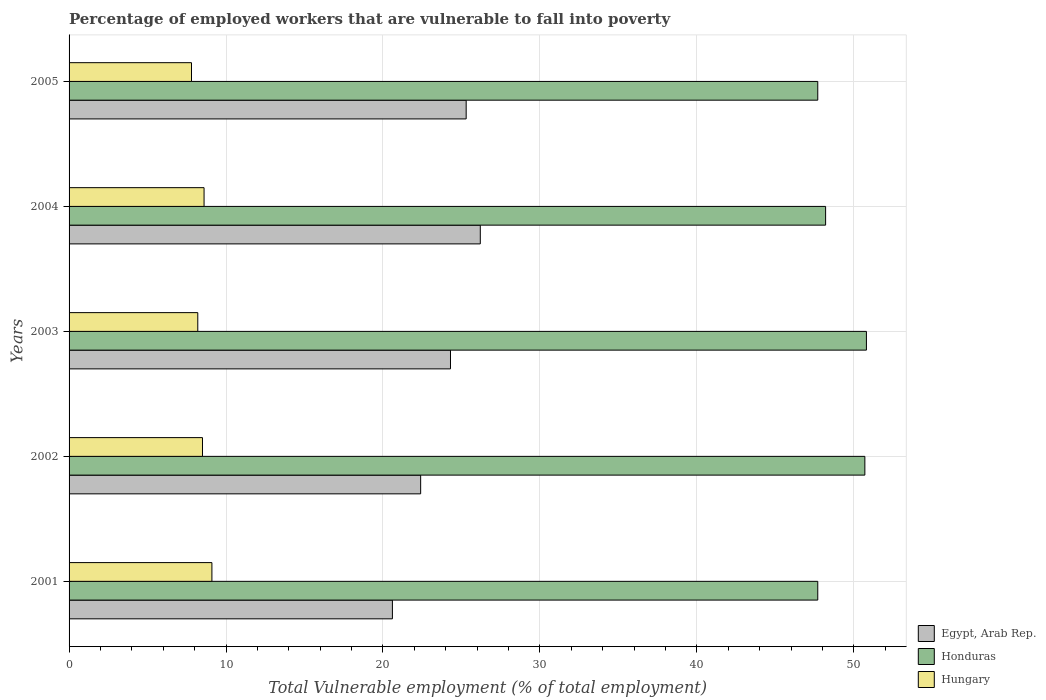How many different coloured bars are there?
Give a very brief answer. 3. How many bars are there on the 1st tick from the top?
Provide a succinct answer. 3. What is the label of the 5th group of bars from the top?
Keep it short and to the point. 2001. What is the percentage of employed workers who are vulnerable to fall into poverty in Egypt, Arab Rep. in 2004?
Your response must be concise. 26.2. Across all years, what is the maximum percentage of employed workers who are vulnerable to fall into poverty in Hungary?
Offer a terse response. 9.1. Across all years, what is the minimum percentage of employed workers who are vulnerable to fall into poverty in Hungary?
Keep it short and to the point. 7.8. What is the total percentage of employed workers who are vulnerable to fall into poverty in Honduras in the graph?
Give a very brief answer. 245.1. What is the difference between the percentage of employed workers who are vulnerable to fall into poverty in Egypt, Arab Rep. in 2001 and that in 2002?
Your response must be concise. -1.8. What is the difference between the percentage of employed workers who are vulnerable to fall into poverty in Honduras in 2004 and the percentage of employed workers who are vulnerable to fall into poverty in Egypt, Arab Rep. in 2001?
Offer a very short reply. 27.6. What is the average percentage of employed workers who are vulnerable to fall into poverty in Honduras per year?
Provide a succinct answer. 49.02. In the year 2001, what is the difference between the percentage of employed workers who are vulnerable to fall into poverty in Egypt, Arab Rep. and percentage of employed workers who are vulnerable to fall into poverty in Honduras?
Give a very brief answer. -27.1. In how many years, is the percentage of employed workers who are vulnerable to fall into poverty in Hungary greater than 12 %?
Provide a short and direct response. 0. What is the ratio of the percentage of employed workers who are vulnerable to fall into poverty in Honduras in 2001 to that in 2002?
Ensure brevity in your answer.  0.94. Is the percentage of employed workers who are vulnerable to fall into poverty in Honduras in 2001 less than that in 2004?
Provide a succinct answer. Yes. Is the difference between the percentage of employed workers who are vulnerable to fall into poverty in Egypt, Arab Rep. in 2001 and 2005 greater than the difference between the percentage of employed workers who are vulnerable to fall into poverty in Honduras in 2001 and 2005?
Provide a short and direct response. No. What is the difference between the highest and the second highest percentage of employed workers who are vulnerable to fall into poverty in Egypt, Arab Rep.?
Keep it short and to the point. 0.9. What is the difference between the highest and the lowest percentage of employed workers who are vulnerable to fall into poverty in Hungary?
Provide a short and direct response. 1.3. In how many years, is the percentage of employed workers who are vulnerable to fall into poverty in Egypt, Arab Rep. greater than the average percentage of employed workers who are vulnerable to fall into poverty in Egypt, Arab Rep. taken over all years?
Ensure brevity in your answer.  3. What does the 1st bar from the top in 2004 represents?
Keep it short and to the point. Hungary. What does the 1st bar from the bottom in 2003 represents?
Your answer should be compact. Egypt, Arab Rep. Are all the bars in the graph horizontal?
Provide a succinct answer. Yes. What is the difference between two consecutive major ticks on the X-axis?
Give a very brief answer. 10. Does the graph contain any zero values?
Ensure brevity in your answer.  No. Where does the legend appear in the graph?
Keep it short and to the point. Bottom right. What is the title of the graph?
Your answer should be compact. Percentage of employed workers that are vulnerable to fall into poverty. Does "Israel" appear as one of the legend labels in the graph?
Keep it short and to the point. No. What is the label or title of the X-axis?
Ensure brevity in your answer.  Total Vulnerable employment (% of total employment). What is the Total Vulnerable employment (% of total employment) of Egypt, Arab Rep. in 2001?
Your answer should be compact. 20.6. What is the Total Vulnerable employment (% of total employment) of Honduras in 2001?
Provide a short and direct response. 47.7. What is the Total Vulnerable employment (% of total employment) of Hungary in 2001?
Keep it short and to the point. 9.1. What is the Total Vulnerable employment (% of total employment) in Egypt, Arab Rep. in 2002?
Give a very brief answer. 22.4. What is the Total Vulnerable employment (% of total employment) in Honduras in 2002?
Make the answer very short. 50.7. What is the Total Vulnerable employment (% of total employment) of Egypt, Arab Rep. in 2003?
Ensure brevity in your answer.  24.3. What is the Total Vulnerable employment (% of total employment) of Honduras in 2003?
Keep it short and to the point. 50.8. What is the Total Vulnerable employment (% of total employment) in Hungary in 2003?
Offer a terse response. 8.2. What is the Total Vulnerable employment (% of total employment) in Egypt, Arab Rep. in 2004?
Provide a succinct answer. 26.2. What is the Total Vulnerable employment (% of total employment) of Honduras in 2004?
Give a very brief answer. 48.2. What is the Total Vulnerable employment (% of total employment) of Hungary in 2004?
Your answer should be compact. 8.6. What is the Total Vulnerable employment (% of total employment) in Egypt, Arab Rep. in 2005?
Your answer should be compact. 25.3. What is the Total Vulnerable employment (% of total employment) in Honduras in 2005?
Provide a succinct answer. 47.7. What is the Total Vulnerable employment (% of total employment) of Hungary in 2005?
Offer a very short reply. 7.8. Across all years, what is the maximum Total Vulnerable employment (% of total employment) in Egypt, Arab Rep.?
Your response must be concise. 26.2. Across all years, what is the maximum Total Vulnerable employment (% of total employment) in Honduras?
Give a very brief answer. 50.8. Across all years, what is the maximum Total Vulnerable employment (% of total employment) of Hungary?
Give a very brief answer. 9.1. Across all years, what is the minimum Total Vulnerable employment (% of total employment) of Egypt, Arab Rep.?
Provide a short and direct response. 20.6. Across all years, what is the minimum Total Vulnerable employment (% of total employment) in Honduras?
Make the answer very short. 47.7. Across all years, what is the minimum Total Vulnerable employment (% of total employment) of Hungary?
Your answer should be very brief. 7.8. What is the total Total Vulnerable employment (% of total employment) in Egypt, Arab Rep. in the graph?
Your answer should be very brief. 118.8. What is the total Total Vulnerable employment (% of total employment) in Honduras in the graph?
Make the answer very short. 245.1. What is the total Total Vulnerable employment (% of total employment) of Hungary in the graph?
Provide a succinct answer. 42.2. What is the difference between the Total Vulnerable employment (% of total employment) of Egypt, Arab Rep. in 2001 and that in 2003?
Your answer should be compact. -3.7. What is the difference between the Total Vulnerable employment (% of total employment) in Honduras in 2001 and that in 2004?
Give a very brief answer. -0.5. What is the difference between the Total Vulnerable employment (% of total employment) of Hungary in 2001 and that in 2004?
Keep it short and to the point. 0.5. What is the difference between the Total Vulnerable employment (% of total employment) in Egypt, Arab Rep. in 2001 and that in 2005?
Your response must be concise. -4.7. What is the difference between the Total Vulnerable employment (% of total employment) of Honduras in 2001 and that in 2005?
Offer a terse response. 0. What is the difference between the Total Vulnerable employment (% of total employment) of Hungary in 2001 and that in 2005?
Provide a succinct answer. 1.3. What is the difference between the Total Vulnerable employment (% of total employment) in Honduras in 2002 and that in 2003?
Provide a succinct answer. -0.1. What is the difference between the Total Vulnerable employment (% of total employment) of Hungary in 2002 and that in 2003?
Your answer should be compact. 0.3. What is the difference between the Total Vulnerable employment (% of total employment) of Egypt, Arab Rep. in 2002 and that in 2004?
Provide a succinct answer. -3.8. What is the difference between the Total Vulnerable employment (% of total employment) of Hungary in 2002 and that in 2004?
Give a very brief answer. -0.1. What is the difference between the Total Vulnerable employment (% of total employment) in Honduras in 2002 and that in 2005?
Your answer should be compact. 3. What is the difference between the Total Vulnerable employment (% of total employment) of Hungary in 2002 and that in 2005?
Give a very brief answer. 0.7. What is the difference between the Total Vulnerable employment (% of total employment) of Honduras in 2003 and that in 2004?
Keep it short and to the point. 2.6. What is the difference between the Total Vulnerable employment (% of total employment) of Hungary in 2003 and that in 2004?
Ensure brevity in your answer.  -0.4. What is the difference between the Total Vulnerable employment (% of total employment) in Egypt, Arab Rep. in 2003 and that in 2005?
Provide a succinct answer. -1. What is the difference between the Total Vulnerable employment (% of total employment) in Hungary in 2003 and that in 2005?
Provide a succinct answer. 0.4. What is the difference between the Total Vulnerable employment (% of total employment) in Egypt, Arab Rep. in 2004 and that in 2005?
Your answer should be compact. 0.9. What is the difference between the Total Vulnerable employment (% of total employment) in Honduras in 2004 and that in 2005?
Ensure brevity in your answer.  0.5. What is the difference between the Total Vulnerable employment (% of total employment) in Hungary in 2004 and that in 2005?
Keep it short and to the point. 0.8. What is the difference between the Total Vulnerable employment (% of total employment) in Egypt, Arab Rep. in 2001 and the Total Vulnerable employment (% of total employment) in Honduras in 2002?
Ensure brevity in your answer.  -30.1. What is the difference between the Total Vulnerable employment (% of total employment) in Honduras in 2001 and the Total Vulnerable employment (% of total employment) in Hungary in 2002?
Offer a terse response. 39.2. What is the difference between the Total Vulnerable employment (% of total employment) in Egypt, Arab Rep. in 2001 and the Total Vulnerable employment (% of total employment) in Honduras in 2003?
Make the answer very short. -30.2. What is the difference between the Total Vulnerable employment (% of total employment) in Honduras in 2001 and the Total Vulnerable employment (% of total employment) in Hungary in 2003?
Provide a succinct answer. 39.5. What is the difference between the Total Vulnerable employment (% of total employment) of Egypt, Arab Rep. in 2001 and the Total Vulnerable employment (% of total employment) of Honduras in 2004?
Give a very brief answer. -27.6. What is the difference between the Total Vulnerable employment (% of total employment) of Honduras in 2001 and the Total Vulnerable employment (% of total employment) of Hungary in 2004?
Your answer should be very brief. 39.1. What is the difference between the Total Vulnerable employment (% of total employment) in Egypt, Arab Rep. in 2001 and the Total Vulnerable employment (% of total employment) in Honduras in 2005?
Offer a terse response. -27.1. What is the difference between the Total Vulnerable employment (% of total employment) of Honduras in 2001 and the Total Vulnerable employment (% of total employment) of Hungary in 2005?
Ensure brevity in your answer.  39.9. What is the difference between the Total Vulnerable employment (% of total employment) of Egypt, Arab Rep. in 2002 and the Total Vulnerable employment (% of total employment) of Honduras in 2003?
Provide a short and direct response. -28.4. What is the difference between the Total Vulnerable employment (% of total employment) of Egypt, Arab Rep. in 2002 and the Total Vulnerable employment (% of total employment) of Hungary in 2003?
Your response must be concise. 14.2. What is the difference between the Total Vulnerable employment (% of total employment) of Honduras in 2002 and the Total Vulnerable employment (% of total employment) of Hungary in 2003?
Give a very brief answer. 42.5. What is the difference between the Total Vulnerable employment (% of total employment) in Egypt, Arab Rep. in 2002 and the Total Vulnerable employment (% of total employment) in Honduras in 2004?
Ensure brevity in your answer.  -25.8. What is the difference between the Total Vulnerable employment (% of total employment) of Honduras in 2002 and the Total Vulnerable employment (% of total employment) of Hungary in 2004?
Give a very brief answer. 42.1. What is the difference between the Total Vulnerable employment (% of total employment) of Egypt, Arab Rep. in 2002 and the Total Vulnerable employment (% of total employment) of Honduras in 2005?
Ensure brevity in your answer.  -25.3. What is the difference between the Total Vulnerable employment (% of total employment) of Egypt, Arab Rep. in 2002 and the Total Vulnerable employment (% of total employment) of Hungary in 2005?
Your answer should be compact. 14.6. What is the difference between the Total Vulnerable employment (% of total employment) in Honduras in 2002 and the Total Vulnerable employment (% of total employment) in Hungary in 2005?
Your answer should be very brief. 42.9. What is the difference between the Total Vulnerable employment (% of total employment) of Egypt, Arab Rep. in 2003 and the Total Vulnerable employment (% of total employment) of Honduras in 2004?
Your answer should be compact. -23.9. What is the difference between the Total Vulnerable employment (% of total employment) in Honduras in 2003 and the Total Vulnerable employment (% of total employment) in Hungary in 2004?
Provide a short and direct response. 42.2. What is the difference between the Total Vulnerable employment (% of total employment) in Egypt, Arab Rep. in 2003 and the Total Vulnerable employment (% of total employment) in Honduras in 2005?
Make the answer very short. -23.4. What is the difference between the Total Vulnerable employment (% of total employment) in Egypt, Arab Rep. in 2004 and the Total Vulnerable employment (% of total employment) in Honduras in 2005?
Offer a terse response. -21.5. What is the difference between the Total Vulnerable employment (% of total employment) in Honduras in 2004 and the Total Vulnerable employment (% of total employment) in Hungary in 2005?
Give a very brief answer. 40.4. What is the average Total Vulnerable employment (% of total employment) in Egypt, Arab Rep. per year?
Provide a short and direct response. 23.76. What is the average Total Vulnerable employment (% of total employment) in Honduras per year?
Ensure brevity in your answer.  49.02. What is the average Total Vulnerable employment (% of total employment) in Hungary per year?
Give a very brief answer. 8.44. In the year 2001, what is the difference between the Total Vulnerable employment (% of total employment) of Egypt, Arab Rep. and Total Vulnerable employment (% of total employment) of Honduras?
Make the answer very short. -27.1. In the year 2001, what is the difference between the Total Vulnerable employment (% of total employment) of Egypt, Arab Rep. and Total Vulnerable employment (% of total employment) of Hungary?
Your response must be concise. 11.5. In the year 2001, what is the difference between the Total Vulnerable employment (% of total employment) in Honduras and Total Vulnerable employment (% of total employment) in Hungary?
Keep it short and to the point. 38.6. In the year 2002, what is the difference between the Total Vulnerable employment (% of total employment) of Egypt, Arab Rep. and Total Vulnerable employment (% of total employment) of Honduras?
Your answer should be compact. -28.3. In the year 2002, what is the difference between the Total Vulnerable employment (% of total employment) of Honduras and Total Vulnerable employment (% of total employment) of Hungary?
Your response must be concise. 42.2. In the year 2003, what is the difference between the Total Vulnerable employment (% of total employment) of Egypt, Arab Rep. and Total Vulnerable employment (% of total employment) of Honduras?
Ensure brevity in your answer.  -26.5. In the year 2003, what is the difference between the Total Vulnerable employment (% of total employment) of Egypt, Arab Rep. and Total Vulnerable employment (% of total employment) of Hungary?
Your answer should be very brief. 16.1. In the year 2003, what is the difference between the Total Vulnerable employment (% of total employment) of Honduras and Total Vulnerable employment (% of total employment) of Hungary?
Your answer should be very brief. 42.6. In the year 2004, what is the difference between the Total Vulnerable employment (% of total employment) of Honduras and Total Vulnerable employment (% of total employment) of Hungary?
Provide a short and direct response. 39.6. In the year 2005, what is the difference between the Total Vulnerable employment (% of total employment) of Egypt, Arab Rep. and Total Vulnerable employment (% of total employment) of Honduras?
Make the answer very short. -22.4. In the year 2005, what is the difference between the Total Vulnerable employment (% of total employment) of Egypt, Arab Rep. and Total Vulnerable employment (% of total employment) of Hungary?
Provide a succinct answer. 17.5. In the year 2005, what is the difference between the Total Vulnerable employment (% of total employment) in Honduras and Total Vulnerable employment (% of total employment) in Hungary?
Give a very brief answer. 39.9. What is the ratio of the Total Vulnerable employment (% of total employment) of Egypt, Arab Rep. in 2001 to that in 2002?
Your answer should be compact. 0.92. What is the ratio of the Total Vulnerable employment (% of total employment) in Honduras in 2001 to that in 2002?
Provide a short and direct response. 0.94. What is the ratio of the Total Vulnerable employment (% of total employment) of Hungary in 2001 to that in 2002?
Make the answer very short. 1.07. What is the ratio of the Total Vulnerable employment (% of total employment) of Egypt, Arab Rep. in 2001 to that in 2003?
Provide a short and direct response. 0.85. What is the ratio of the Total Vulnerable employment (% of total employment) in Honduras in 2001 to that in 2003?
Your answer should be compact. 0.94. What is the ratio of the Total Vulnerable employment (% of total employment) in Hungary in 2001 to that in 2003?
Give a very brief answer. 1.11. What is the ratio of the Total Vulnerable employment (% of total employment) of Egypt, Arab Rep. in 2001 to that in 2004?
Give a very brief answer. 0.79. What is the ratio of the Total Vulnerable employment (% of total employment) in Hungary in 2001 to that in 2004?
Offer a terse response. 1.06. What is the ratio of the Total Vulnerable employment (% of total employment) of Egypt, Arab Rep. in 2001 to that in 2005?
Offer a very short reply. 0.81. What is the ratio of the Total Vulnerable employment (% of total employment) of Honduras in 2001 to that in 2005?
Offer a very short reply. 1. What is the ratio of the Total Vulnerable employment (% of total employment) of Egypt, Arab Rep. in 2002 to that in 2003?
Offer a very short reply. 0.92. What is the ratio of the Total Vulnerable employment (% of total employment) of Honduras in 2002 to that in 2003?
Keep it short and to the point. 1. What is the ratio of the Total Vulnerable employment (% of total employment) in Hungary in 2002 to that in 2003?
Make the answer very short. 1.04. What is the ratio of the Total Vulnerable employment (% of total employment) of Egypt, Arab Rep. in 2002 to that in 2004?
Provide a short and direct response. 0.85. What is the ratio of the Total Vulnerable employment (% of total employment) of Honduras in 2002 to that in 2004?
Your answer should be compact. 1.05. What is the ratio of the Total Vulnerable employment (% of total employment) in Hungary in 2002 to that in 2004?
Provide a succinct answer. 0.99. What is the ratio of the Total Vulnerable employment (% of total employment) of Egypt, Arab Rep. in 2002 to that in 2005?
Offer a terse response. 0.89. What is the ratio of the Total Vulnerable employment (% of total employment) in Honduras in 2002 to that in 2005?
Ensure brevity in your answer.  1.06. What is the ratio of the Total Vulnerable employment (% of total employment) of Hungary in 2002 to that in 2005?
Your answer should be compact. 1.09. What is the ratio of the Total Vulnerable employment (% of total employment) in Egypt, Arab Rep. in 2003 to that in 2004?
Your answer should be compact. 0.93. What is the ratio of the Total Vulnerable employment (% of total employment) in Honduras in 2003 to that in 2004?
Your answer should be very brief. 1.05. What is the ratio of the Total Vulnerable employment (% of total employment) of Hungary in 2003 to that in 2004?
Provide a short and direct response. 0.95. What is the ratio of the Total Vulnerable employment (% of total employment) in Egypt, Arab Rep. in 2003 to that in 2005?
Offer a very short reply. 0.96. What is the ratio of the Total Vulnerable employment (% of total employment) in Honduras in 2003 to that in 2005?
Offer a very short reply. 1.06. What is the ratio of the Total Vulnerable employment (% of total employment) in Hungary in 2003 to that in 2005?
Your answer should be compact. 1.05. What is the ratio of the Total Vulnerable employment (% of total employment) of Egypt, Arab Rep. in 2004 to that in 2005?
Offer a terse response. 1.04. What is the ratio of the Total Vulnerable employment (% of total employment) of Honduras in 2004 to that in 2005?
Offer a very short reply. 1.01. What is the ratio of the Total Vulnerable employment (% of total employment) of Hungary in 2004 to that in 2005?
Offer a very short reply. 1.1. What is the difference between the highest and the second highest Total Vulnerable employment (% of total employment) in Egypt, Arab Rep.?
Keep it short and to the point. 0.9. What is the difference between the highest and the lowest Total Vulnerable employment (% of total employment) in Egypt, Arab Rep.?
Offer a terse response. 5.6. What is the difference between the highest and the lowest Total Vulnerable employment (% of total employment) in Hungary?
Your answer should be very brief. 1.3. 